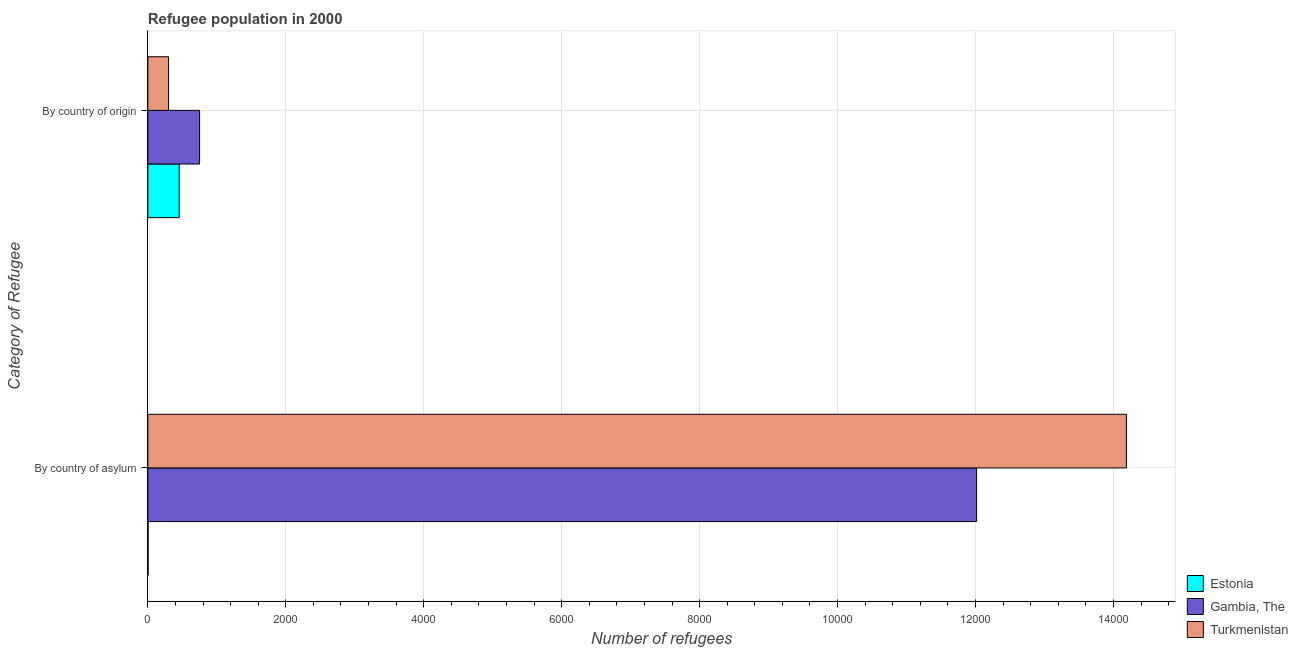How many different coloured bars are there?
Your answer should be compact. 3. Are the number of bars per tick equal to the number of legend labels?
Offer a very short reply. Yes. How many bars are there on the 2nd tick from the top?
Give a very brief answer. 3. What is the label of the 2nd group of bars from the top?
Keep it short and to the point. By country of asylum. What is the number of refugees by country of asylum in Turkmenistan?
Give a very brief answer. 1.42e+04. Across all countries, what is the maximum number of refugees by country of asylum?
Offer a terse response. 1.42e+04. Across all countries, what is the minimum number of refugees by country of origin?
Provide a short and direct response. 300. In which country was the number of refugees by country of origin maximum?
Your response must be concise. Gambia, The. In which country was the number of refugees by country of origin minimum?
Provide a short and direct response. Turkmenistan. What is the total number of refugees by country of origin in the graph?
Give a very brief answer. 1505. What is the difference between the number of refugees by country of origin in Turkmenistan and that in Gambia, The?
Give a very brief answer. -450. What is the difference between the number of refugees by country of asylum in Gambia, The and the number of refugees by country of origin in Estonia?
Offer a very short reply. 1.16e+04. What is the average number of refugees by country of asylum per country?
Provide a short and direct response. 8736. What is the difference between the number of refugees by country of asylum and number of refugees by country of origin in Turkmenistan?
Your answer should be very brief. 1.39e+04. In how many countries, is the number of refugees by country of origin greater than 8400 ?
Keep it short and to the point. 0. What is the ratio of the number of refugees by country of origin in Estonia to that in Gambia, The?
Your answer should be very brief. 0.61. In how many countries, is the number of refugees by country of origin greater than the average number of refugees by country of origin taken over all countries?
Offer a very short reply. 1. What does the 1st bar from the top in By country of origin represents?
Offer a terse response. Turkmenistan. What does the 1st bar from the bottom in By country of asylum represents?
Offer a terse response. Estonia. What is the difference between two consecutive major ticks on the X-axis?
Ensure brevity in your answer.  2000. Are the values on the major ticks of X-axis written in scientific E-notation?
Provide a short and direct response. No. Does the graph contain any zero values?
Offer a terse response. No. Where does the legend appear in the graph?
Your response must be concise. Bottom right. What is the title of the graph?
Ensure brevity in your answer.  Refugee population in 2000. What is the label or title of the X-axis?
Give a very brief answer. Number of refugees. What is the label or title of the Y-axis?
Your response must be concise. Category of Refugee. What is the Number of refugees of Estonia in By country of asylum?
Offer a very short reply. 4. What is the Number of refugees in Gambia, The in By country of asylum?
Provide a short and direct response. 1.20e+04. What is the Number of refugees in Turkmenistan in By country of asylum?
Offer a terse response. 1.42e+04. What is the Number of refugees of Estonia in By country of origin?
Your answer should be very brief. 455. What is the Number of refugees of Gambia, The in By country of origin?
Ensure brevity in your answer.  750. What is the Number of refugees of Turkmenistan in By country of origin?
Give a very brief answer. 300. Across all Category of Refugee, what is the maximum Number of refugees of Estonia?
Offer a terse response. 455. Across all Category of Refugee, what is the maximum Number of refugees in Gambia, The?
Provide a short and direct response. 1.20e+04. Across all Category of Refugee, what is the maximum Number of refugees in Turkmenistan?
Give a very brief answer. 1.42e+04. Across all Category of Refugee, what is the minimum Number of refugees in Estonia?
Provide a succinct answer. 4. Across all Category of Refugee, what is the minimum Number of refugees in Gambia, The?
Offer a very short reply. 750. Across all Category of Refugee, what is the minimum Number of refugees of Turkmenistan?
Your response must be concise. 300. What is the total Number of refugees of Estonia in the graph?
Keep it short and to the point. 459. What is the total Number of refugees in Gambia, The in the graph?
Provide a succinct answer. 1.28e+04. What is the total Number of refugees in Turkmenistan in the graph?
Provide a succinct answer. 1.45e+04. What is the difference between the Number of refugees in Estonia in By country of asylum and that in By country of origin?
Offer a terse response. -451. What is the difference between the Number of refugees in Gambia, The in By country of asylum and that in By country of origin?
Keep it short and to the point. 1.13e+04. What is the difference between the Number of refugees of Turkmenistan in By country of asylum and that in By country of origin?
Ensure brevity in your answer.  1.39e+04. What is the difference between the Number of refugees in Estonia in By country of asylum and the Number of refugees in Gambia, The in By country of origin?
Your answer should be very brief. -746. What is the difference between the Number of refugees in Estonia in By country of asylum and the Number of refugees in Turkmenistan in By country of origin?
Your answer should be very brief. -296. What is the difference between the Number of refugees in Gambia, The in By country of asylum and the Number of refugees in Turkmenistan in By country of origin?
Ensure brevity in your answer.  1.17e+04. What is the average Number of refugees of Estonia per Category of Refugee?
Offer a very short reply. 229.5. What is the average Number of refugees of Gambia, The per Category of Refugee?
Offer a terse response. 6383. What is the average Number of refugees of Turkmenistan per Category of Refugee?
Ensure brevity in your answer.  7244. What is the difference between the Number of refugees in Estonia and Number of refugees in Gambia, The in By country of asylum?
Make the answer very short. -1.20e+04. What is the difference between the Number of refugees of Estonia and Number of refugees of Turkmenistan in By country of asylum?
Give a very brief answer. -1.42e+04. What is the difference between the Number of refugees of Gambia, The and Number of refugees of Turkmenistan in By country of asylum?
Provide a succinct answer. -2172. What is the difference between the Number of refugees of Estonia and Number of refugees of Gambia, The in By country of origin?
Your answer should be very brief. -295. What is the difference between the Number of refugees in Estonia and Number of refugees in Turkmenistan in By country of origin?
Your answer should be very brief. 155. What is the difference between the Number of refugees in Gambia, The and Number of refugees in Turkmenistan in By country of origin?
Give a very brief answer. 450. What is the ratio of the Number of refugees in Estonia in By country of asylum to that in By country of origin?
Offer a terse response. 0.01. What is the ratio of the Number of refugees of Gambia, The in By country of asylum to that in By country of origin?
Ensure brevity in your answer.  16.02. What is the ratio of the Number of refugees in Turkmenistan in By country of asylum to that in By country of origin?
Give a very brief answer. 47.29. What is the difference between the highest and the second highest Number of refugees of Estonia?
Give a very brief answer. 451. What is the difference between the highest and the second highest Number of refugees in Gambia, The?
Offer a very short reply. 1.13e+04. What is the difference between the highest and the second highest Number of refugees in Turkmenistan?
Your response must be concise. 1.39e+04. What is the difference between the highest and the lowest Number of refugees of Estonia?
Keep it short and to the point. 451. What is the difference between the highest and the lowest Number of refugees of Gambia, The?
Your answer should be very brief. 1.13e+04. What is the difference between the highest and the lowest Number of refugees in Turkmenistan?
Offer a terse response. 1.39e+04. 